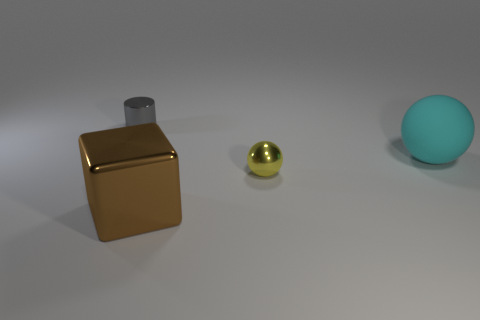Subtract 1 spheres. How many spheres are left? 1 Add 2 gray metal cylinders. How many objects exist? 6 Subtract all red cylinders. Subtract all gray balls. How many cylinders are left? 1 Subtract all brown shiny objects. Subtract all big purple spheres. How many objects are left? 3 Add 4 tiny yellow things. How many tiny yellow things are left? 5 Add 4 cubes. How many cubes exist? 5 Subtract 0 red cylinders. How many objects are left? 4 